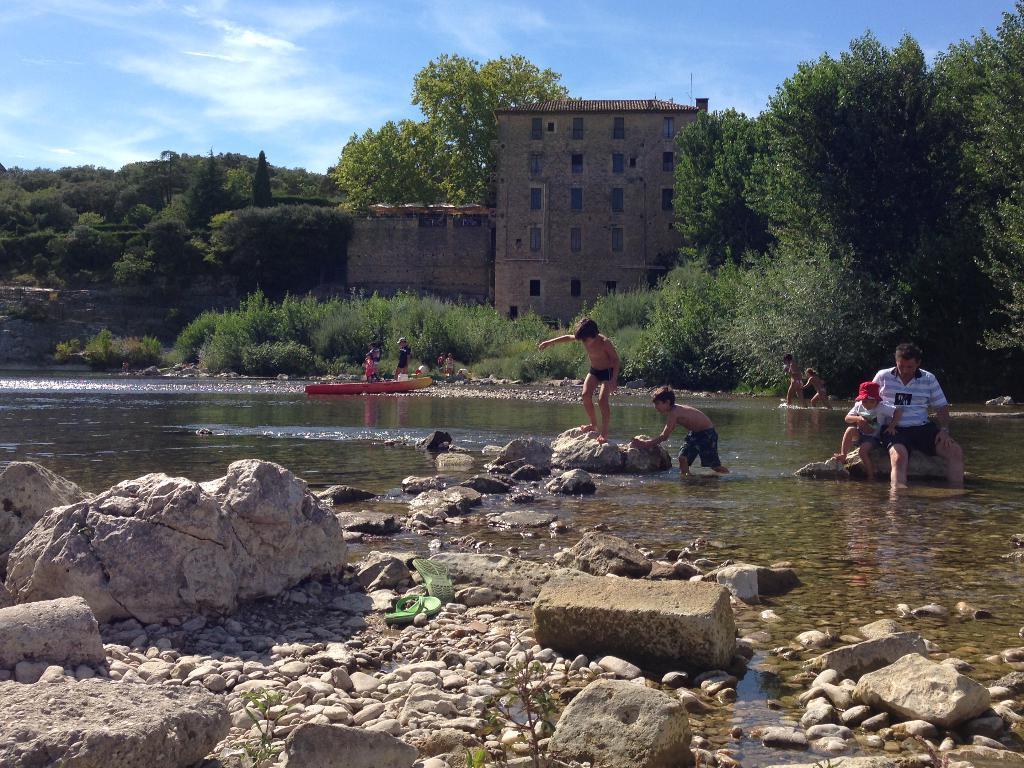Please provide a concise description of this image. In this picture we can see few rocks and group of people, few are seated, few are standing and few are playing in the water, in the background we can find a boat, few trees and a building. 